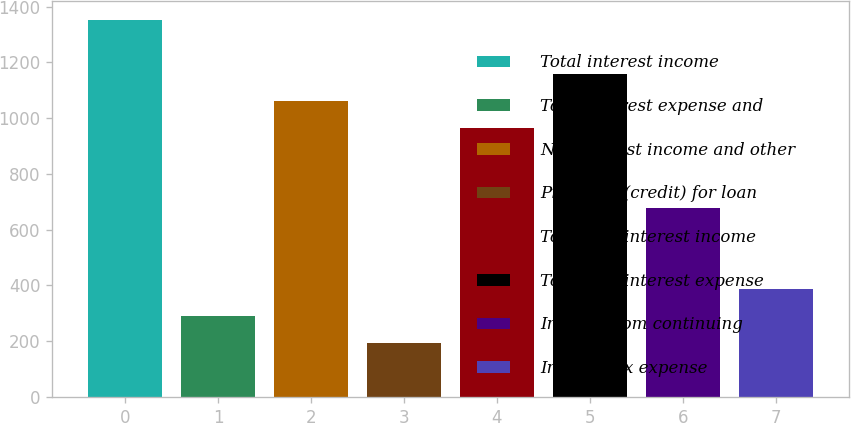<chart> <loc_0><loc_0><loc_500><loc_500><bar_chart><fcel>Total interest income<fcel>Total interest expense and<fcel>Net interest income and other<fcel>Provision (credit) for loan<fcel>Total non-interest income<fcel>Total non-interest expense<fcel>Income from continuing<fcel>Income tax expense<nl><fcel>1352.35<fcel>289.97<fcel>1062.61<fcel>193.39<fcel>966.03<fcel>1159.19<fcel>676.29<fcel>386.55<nl></chart> 